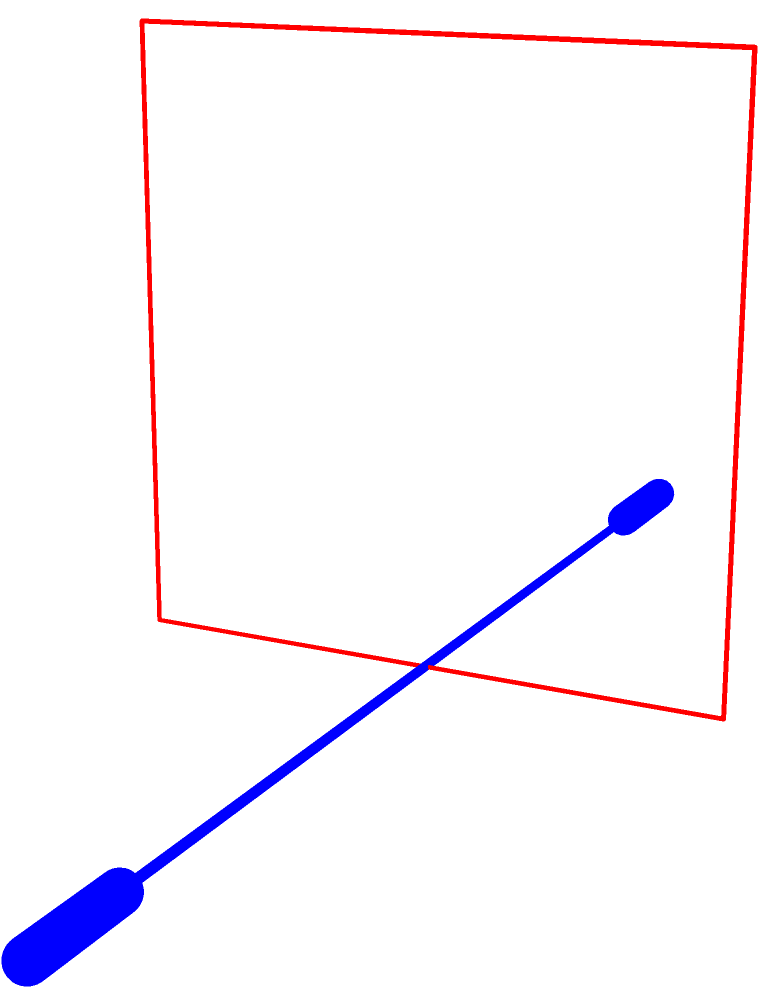A standard Olympic barbell is 7 feet (2.2 meters) long. The narrow doorway to your home gym is only 6 feet (1.8 meters) high. What's the minimum angle you need to rotate the barbell to fit it through the doorway? Let's approach this step-by-step:

1) We can treat this as a right triangle problem, where:
   - The hypotenuse is the length of the barbell (7 feet)
   - The adjacent side is the height of the doorway (6 feet)

2) We need to find the angle θ between the barbell and the horizontal.

3) We can use the cosine function to solve this:

   $\cos(\theta) = \frac{\text{adjacent}}{\text{hypotenuse}} = \frac{6}{7}$

4) To find θ, we need to take the inverse cosine (arccos):

   $\theta = \arccos(\frac{6}{7})$

5) Using a calculator or computer:

   $\theta \approx 31.0° \text{ (rounded to one decimal place)}$

6) This is the angle from the horizontal. The question asks for the minimum rotation angle, which would be from vertical. To get this, we subtract our result from 90°:

   $90° - 31.0° = 59.0°$
Answer: 59.0° 